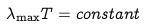Convert formula to latex. <formula><loc_0><loc_0><loc_500><loc_500>\lambda _ { \max } T = c o n s t a n t</formula> 